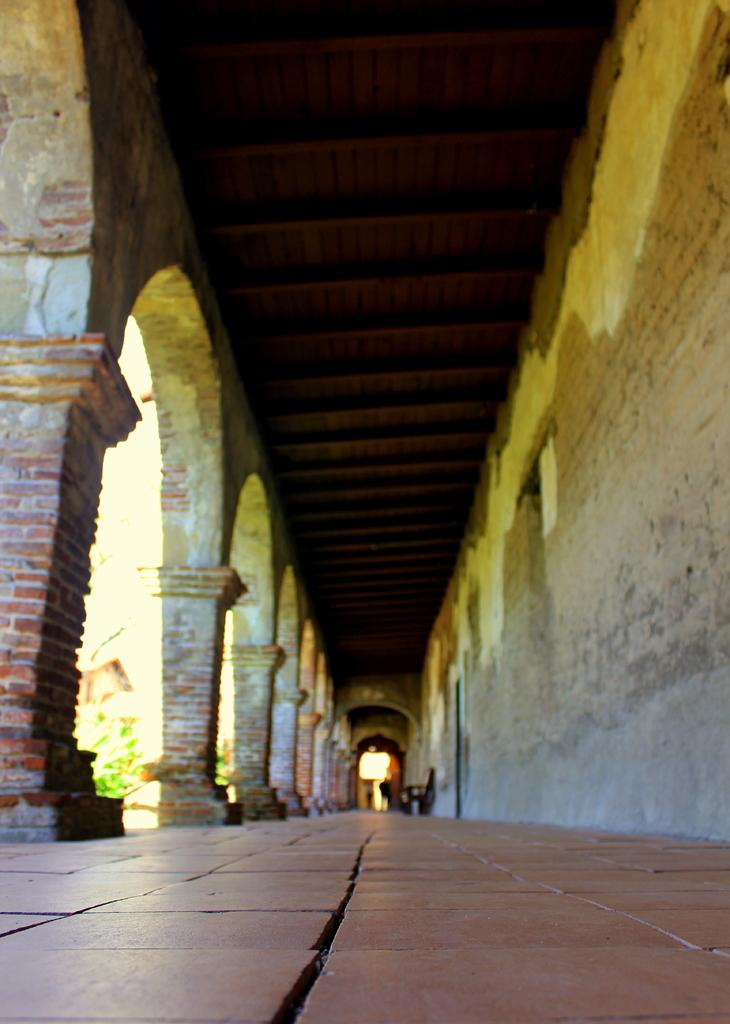What architectural feature can be seen on the building in the image? There are arches on the building in the image. What object is located on the path in the image? There is a chair on the path in the image. What can be seen outside the building in the image? There are plants visible outside the building in the image. What type of fish can be seen swimming in the fountain in the image? There is no fountain or fish present in the image. 